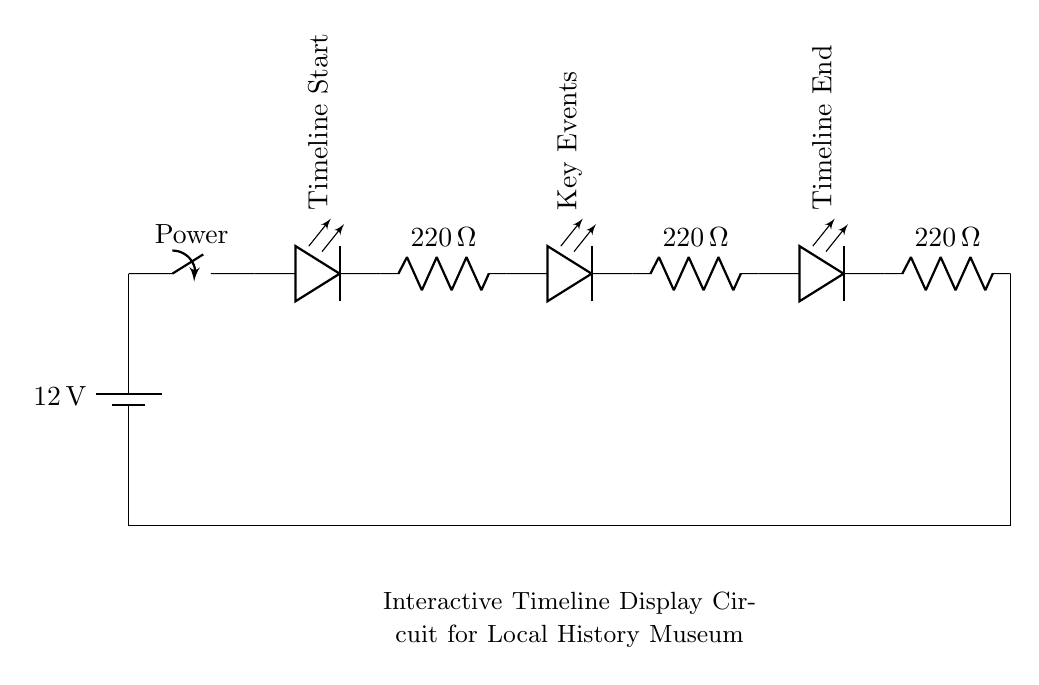What is the voltage of this circuit? The voltage is 12 volts, which is indicated by the battery symbol at the beginning of the circuit diagram.
Answer: 12 volts What components are used in this circuit? The circuit consists of a battery, three LEDs, three resistors, and a switch. These are the primary components depicted in the diagram.
Answer: Battery, LEDs, resistors, switch How many LEDs are in this circuit? There are three LEDs in total, labeled as Timeline Start, Key Events, and Timeline End in the diagram.
Answer: Three What is the resistance value of each resistor? Each resistor is labeled with a resistance value of 220 ohms, which can be seen next to each resistor symbol in the circuit diagram.
Answer: 220 ohms What type of circuit is this? This is a series circuit, as all components are connected in a single path, allowing current to flow through each component sequentially.
Answer: Series circuit What effect does the switch have on the circuit? The switch controls the flow of current; when it's closed, it completes the circuit and allows the LEDs to light up. When it's open, the current stops, and the LEDs do not illuminate.
Answer: Control current How is the circuit completed? The circuit is completed by connecting the last component back to the battery, creating a single continuous loop from battery through the components back to the battery.
Answer: Closed loop connection 